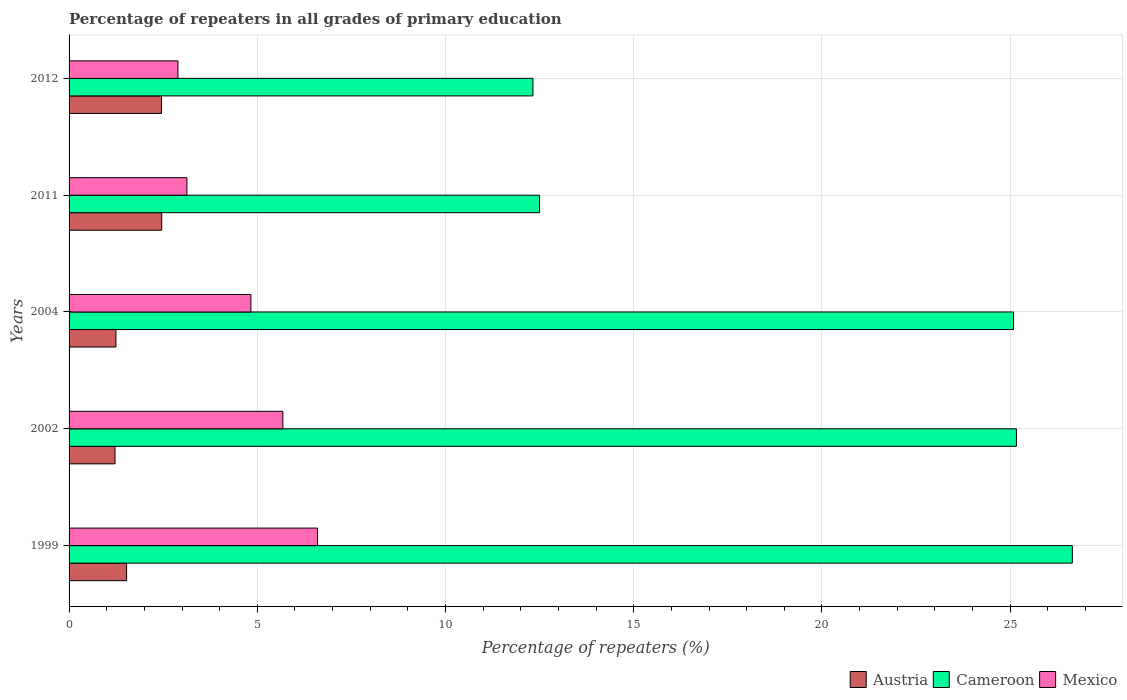How many different coloured bars are there?
Provide a short and direct response. 3. How many groups of bars are there?
Provide a succinct answer. 5. Are the number of bars per tick equal to the number of legend labels?
Your answer should be very brief. Yes. How many bars are there on the 2nd tick from the top?
Your answer should be very brief. 3. What is the label of the 2nd group of bars from the top?
Give a very brief answer. 2011. What is the percentage of repeaters in Cameroon in 2011?
Your response must be concise. 12.5. Across all years, what is the maximum percentage of repeaters in Austria?
Your answer should be compact. 2.46. Across all years, what is the minimum percentage of repeaters in Austria?
Give a very brief answer. 1.22. In which year was the percentage of repeaters in Cameroon minimum?
Provide a short and direct response. 2012. What is the total percentage of repeaters in Austria in the graph?
Offer a very short reply. 8.91. What is the difference between the percentage of repeaters in Cameroon in 1999 and that in 2004?
Keep it short and to the point. 1.56. What is the difference between the percentage of repeaters in Cameroon in 2012 and the percentage of repeaters in Mexico in 2002?
Keep it short and to the point. 6.64. What is the average percentage of repeaters in Austria per year?
Your response must be concise. 1.78. In the year 2002, what is the difference between the percentage of repeaters in Austria and percentage of repeaters in Mexico?
Your response must be concise. -4.46. In how many years, is the percentage of repeaters in Mexico greater than 16 %?
Offer a terse response. 0. What is the ratio of the percentage of repeaters in Mexico in 2004 to that in 2011?
Offer a very short reply. 1.54. Is the percentage of repeaters in Mexico in 1999 less than that in 2011?
Make the answer very short. No. Is the difference between the percentage of repeaters in Austria in 1999 and 2012 greater than the difference between the percentage of repeaters in Mexico in 1999 and 2012?
Ensure brevity in your answer.  No. What is the difference between the highest and the second highest percentage of repeaters in Cameroon?
Keep it short and to the point. 1.48. What is the difference between the highest and the lowest percentage of repeaters in Austria?
Provide a short and direct response. 1.24. In how many years, is the percentage of repeaters in Austria greater than the average percentage of repeaters in Austria taken over all years?
Offer a terse response. 2. What does the 2nd bar from the bottom in 2012 represents?
Your answer should be compact. Cameroon. Are the values on the major ticks of X-axis written in scientific E-notation?
Keep it short and to the point. No. Where does the legend appear in the graph?
Make the answer very short. Bottom right. How many legend labels are there?
Provide a short and direct response. 3. How are the legend labels stacked?
Give a very brief answer. Horizontal. What is the title of the graph?
Your answer should be compact. Percentage of repeaters in all grades of primary education. Does "Eritrea" appear as one of the legend labels in the graph?
Provide a succinct answer. No. What is the label or title of the X-axis?
Your response must be concise. Percentage of repeaters (%). What is the Percentage of repeaters (%) in Austria in 1999?
Offer a very short reply. 1.53. What is the Percentage of repeaters (%) in Cameroon in 1999?
Provide a short and direct response. 26.65. What is the Percentage of repeaters (%) of Mexico in 1999?
Your response must be concise. 6.6. What is the Percentage of repeaters (%) in Austria in 2002?
Ensure brevity in your answer.  1.22. What is the Percentage of repeaters (%) of Cameroon in 2002?
Give a very brief answer. 25.17. What is the Percentage of repeaters (%) in Mexico in 2002?
Provide a succinct answer. 5.68. What is the Percentage of repeaters (%) in Austria in 2004?
Your response must be concise. 1.24. What is the Percentage of repeaters (%) in Cameroon in 2004?
Provide a succinct answer. 25.09. What is the Percentage of repeaters (%) in Mexico in 2004?
Keep it short and to the point. 4.83. What is the Percentage of repeaters (%) in Austria in 2011?
Provide a short and direct response. 2.46. What is the Percentage of repeaters (%) of Cameroon in 2011?
Offer a terse response. 12.5. What is the Percentage of repeaters (%) of Mexico in 2011?
Provide a short and direct response. 3.13. What is the Percentage of repeaters (%) of Austria in 2012?
Provide a succinct answer. 2.46. What is the Percentage of repeaters (%) in Cameroon in 2012?
Give a very brief answer. 12.32. What is the Percentage of repeaters (%) of Mexico in 2012?
Give a very brief answer. 2.89. Across all years, what is the maximum Percentage of repeaters (%) of Austria?
Make the answer very short. 2.46. Across all years, what is the maximum Percentage of repeaters (%) of Cameroon?
Your answer should be compact. 26.65. Across all years, what is the maximum Percentage of repeaters (%) in Mexico?
Make the answer very short. 6.6. Across all years, what is the minimum Percentage of repeaters (%) of Austria?
Provide a succinct answer. 1.22. Across all years, what is the minimum Percentage of repeaters (%) of Cameroon?
Give a very brief answer. 12.32. Across all years, what is the minimum Percentage of repeaters (%) in Mexico?
Your response must be concise. 2.89. What is the total Percentage of repeaters (%) of Austria in the graph?
Keep it short and to the point. 8.91. What is the total Percentage of repeaters (%) of Cameroon in the graph?
Ensure brevity in your answer.  101.72. What is the total Percentage of repeaters (%) of Mexico in the graph?
Offer a very short reply. 23.13. What is the difference between the Percentage of repeaters (%) in Austria in 1999 and that in 2002?
Keep it short and to the point. 0.31. What is the difference between the Percentage of repeaters (%) in Cameroon in 1999 and that in 2002?
Make the answer very short. 1.48. What is the difference between the Percentage of repeaters (%) in Mexico in 1999 and that in 2002?
Ensure brevity in your answer.  0.92. What is the difference between the Percentage of repeaters (%) in Austria in 1999 and that in 2004?
Offer a terse response. 0.28. What is the difference between the Percentage of repeaters (%) of Cameroon in 1999 and that in 2004?
Offer a terse response. 1.56. What is the difference between the Percentage of repeaters (%) in Mexico in 1999 and that in 2004?
Offer a very short reply. 1.77. What is the difference between the Percentage of repeaters (%) of Austria in 1999 and that in 2011?
Your answer should be very brief. -0.93. What is the difference between the Percentage of repeaters (%) of Cameroon in 1999 and that in 2011?
Ensure brevity in your answer.  14.15. What is the difference between the Percentage of repeaters (%) of Mexico in 1999 and that in 2011?
Your answer should be compact. 3.47. What is the difference between the Percentage of repeaters (%) of Austria in 1999 and that in 2012?
Your answer should be very brief. -0.93. What is the difference between the Percentage of repeaters (%) in Cameroon in 1999 and that in 2012?
Make the answer very short. 14.33. What is the difference between the Percentage of repeaters (%) of Mexico in 1999 and that in 2012?
Keep it short and to the point. 3.71. What is the difference between the Percentage of repeaters (%) of Austria in 2002 and that in 2004?
Ensure brevity in your answer.  -0.02. What is the difference between the Percentage of repeaters (%) in Cameroon in 2002 and that in 2004?
Give a very brief answer. 0.08. What is the difference between the Percentage of repeaters (%) in Mexico in 2002 and that in 2004?
Give a very brief answer. 0.85. What is the difference between the Percentage of repeaters (%) in Austria in 2002 and that in 2011?
Your answer should be compact. -1.24. What is the difference between the Percentage of repeaters (%) of Cameroon in 2002 and that in 2011?
Keep it short and to the point. 12.67. What is the difference between the Percentage of repeaters (%) in Mexico in 2002 and that in 2011?
Provide a succinct answer. 2.55. What is the difference between the Percentage of repeaters (%) in Austria in 2002 and that in 2012?
Keep it short and to the point. -1.24. What is the difference between the Percentage of repeaters (%) in Cameroon in 2002 and that in 2012?
Keep it short and to the point. 12.84. What is the difference between the Percentage of repeaters (%) of Mexico in 2002 and that in 2012?
Make the answer very short. 2.79. What is the difference between the Percentage of repeaters (%) in Austria in 2004 and that in 2011?
Your answer should be compact. -1.22. What is the difference between the Percentage of repeaters (%) in Cameroon in 2004 and that in 2011?
Make the answer very short. 12.59. What is the difference between the Percentage of repeaters (%) of Mexico in 2004 and that in 2011?
Offer a very short reply. 1.7. What is the difference between the Percentage of repeaters (%) of Austria in 2004 and that in 2012?
Provide a succinct answer. -1.21. What is the difference between the Percentage of repeaters (%) in Cameroon in 2004 and that in 2012?
Provide a short and direct response. 12.77. What is the difference between the Percentage of repeaters (%) of Mexico in 2004 and that in 2012?
Ensure brevity in your answer.  1.94. What is the difference between the Percentage of repeaters (%) in Austria in 2011 and that in 2012?
Your answer should be compact. 0. What is the difference between the Percentage of repeaters (%) of Cameroon in 2011 and that in 2012?
Offer a very short reply. 0.17. What is the difference between the Percentage of repeaters (%) of Mexico in 2011 and that in 2012?
Offer a terse response. 0.24. What is the difference between the Percentage of repeaters (%) in Austria in 1999 and the Percentage of repeaters (%) in Cameroon in 2002?
Keep it short and to the point. -23.64. What is the difference between the Percentage of repeaters (%) of Austria in 1999 and the Percentage of repeaters (%) of Mexico in 2002?
Offer a very short reply. -4.15. What is the difference between the Percentage of repeaters (%) in Cameroon in 1999 and the Percentage of repeaters (%) in Mexico in 2002?
Your answer should be compact. 20.97. What is the difference between the Percentage of repeaters (%) of Austria in 1999 and the Percentage of repeaters (%) of Cameroon in 2004?
Ensure brevity in your answer.  -23.56. What is the difference between the Percentage of repeaters (%) in Austria in 1999 and the Percentage of repeaters (%) in Mexico in 2004?
Your answer should be compact. -3.3. What is the difference between the Percentage of repeaters (%) of Cameroon in 1999 and the Percentage of repeaters (%) of Mexico in 2004?
Offer a terse response. 21.82. What is the difference between the Percentage of repeaters (%) of Austria in 1999 and the Percentage of repeaters (%) of Cameroon in 2011?
Your response must be concise. -10.97. What is the difference between the Percentage of repeaters (%) in Austria in 1999 and the Percentage of repeaters (%) in Mexico in 2011?
Make the answer very short. -1.6. What is the difference between the Percentage of repeaters (%) in Cameroon in 1999 and the Percentage of repeaters (%) in Mexico in 2011?
Offer a very short reply. 23.52. What is the difference between the Percentage of repeaters (%) of Austria in 1999 and the Percentage of repeaters (%) of Cameroon in 2012?
Your answer should be very brief. -10.79. What is the difference between the Percentage of repeaters (%) of Austria in 1999 and the Percentage of repeaters (%) of Mexico in 2012?
Make the answer very short. -1.36. What is the difference between the Percentage of repeaters (%) of Cameroon in 1999 and the Percentage of repeaters (%) of Mexico in 2012?
Provide a succinct answer. 23.76. What is the difference between the Percentage of repeaters (%) in Austria in 2002 and the Percentage of repeaters (%) in Cameroon in 2004?
Your answer should be very brief. -23.87. What is the difference between the Percentage of repeaters (%) in Austria in 2002 and the Percentage of repeaters (%) in Mexico in 2004?
Give a very brief answer. -3.61. What is the difference between the Percentage of repeaters (%) of Cameroon in 2002 and the Percentage of repeaters (%) of Mexico in 2004?
Give a very brief answer. 20.34. What is the difference between the Percentage of repeaters (%) in Austria in 2002 and the Percentage of repeaters (%) in Cameroon in 2011?
Give a very brief answer. -11.28. What is the difference between the Percentage of repeaters (%) of Austria in 2002 and the Percentage of repeaters (%) of Mexico in 2011?
Provide a short and direct response. -1.91. What is the difference between the Percentage of repeaters (%) in Cameroon in 2002 and the Percentage of repeaters (%) in Mexico in 2011?
Your answer should be compact. 22.04. What is the difference between the Percentage of repeaters (%) in Austria in 2002 and the Percentage of repeaters (%) in Cameroon in 2012?
Your answer should be very brief. -11.1. What is the difference between the Percentage of repeaters (%) of Austria in 2002 and the Percentage of repeaters (%) of Mexico in 2012?
Provide a short and direct response. -1.67. What is the difference between the Percentage of repeaters (%) in Cameroon in 2002 and the Percentage of repeaters (%) in Mexico in 2012?
Make the answer very short. 22.27. What is the difference between the Percentage of repeaters (%) in Austria in 2004 and the Percentage of repeaters (%) in Cameroon in 2011?
Make the answer very short. -11.25. What is the difference between the Percentage of repeaters (%) of Austria in 2004 and the Percentage of repeaters (%) of Mexico in 2011?
Your answer should be compact. -1.88. What is the difference between the Percentage of repeaters (%) in Cameroon in 2004 and the Percentage of repeaters (%) in Mexico in 2011?
Your response must be concise. 21.96. What is the difference between the Percentage of repeaters (%) of Austria in 2004 and the Percentage of repeaters (%) of Cameroon in 2012?
Ensure brevity in your answer.  -11.08. What is the difference between the Percentage of repeaters (%) in Austria in 2004 and the Percentage of repeaters (%) in Mexico in 2012?
Your response must be concise. -1.65. What is the difference between the Percentage of repeaters (%) in Cameroon in 2004 and the Percentage of repeaters (%) in Mexico in 2012?
Provide a short and direct response. 22.2. What is the difference between the Percentage of repeaters (%) of Austria in 2011 and the Percentage of repeaters (%) of Cameroon in 2012?
Offer a terse response. -9.86. What is the difference between the Percentage of repeaters (%) of Austria in 2011 and the Percentage of repeaters (%) of Mexico in 2012?
Offer a very short reply. -0.43. What is the difference between the Percentage of repeaters (%) of Cameroon in 2011 and the Percentage of repeaters (%) of Mexico in 2012?
Make the answer very short. 9.6. What is the average Percentage of repeaters (%) of Austria per year?
Keep it short and to the point. 1.78. What is the average Percentage of repeaters (%) in Cameroon per year?
Offer a terse response. 20.34. What is the average Percentage of repeaters (%) in Mexico per year?
Your answer should be very brief. 4.63. In the year 1999, what is the difference between the Percentage of repeaters (%) in Austria and Percentage of repeaters (%) in Cameroon?
Your answer should be compact. -25.12. In the year 1999, what is the difference between the Percentage of repeaters (%) in Austria and Percentage of repeaters (%) in Mexico?
Offer a very short reply. -5.07. In the year 1999, what is the difference between the Percentage of repeaters (%) of Cameroon and Percentage of repeaters (%) of Mexico?
Your response must be concise. 20.05. In the year 2002, what is the difference between the Percentage of repeaters (%) of Austria and Percentage of repeaters (%) of Cameroon?
Your answer should be compact. -23.94. In the year 2002, what is the difference between the Percentage of repeaters (%) of Austria and Percentage of repeaters (%) of Mexico?
Keep it short and to the point. -4.46. In the year 2002, what is the difference between the Percentage of repeaters (%) of Cameroon and Percentage of repeaters (%) of Mexico?
Provide a succinct answer. 19.49. In the year 2004, what is the difference between the Percentage of repeaters (%) in Austria and Percentage of repeaters (%) in Cameroon?
Provide a short and direct response. -23.84. In the year 2004, what is the difference between the Percentage of repeaters (%) in Austria and Percentage of repeaters (%) in Mexico?
Ensure brevity in your answer.  -3.58. In the year 2004, what is the difference between the Percentage of repeaters (%) in Cameroon and Percentage of repeaters (%) in Mexico?
Keep it short and to the point. 20.26. In the year 2011, what is the difference between the Percentage of repeaters (%) in Austria and Percentage of repeaters (%) in Cameroon?
Provide a short and direct response. -10.03. In the year 2011, what is the difference between the Percentage of repeaters (%) in Austria and Percentage of repeaters (%) in Mexico?
Offer a terse response. -0.67. In the year 2011, what is the difference between the Percentage of repeaters (%) of Cameroon and Percentage of repeaters (%) of Mexico?
Keep it short and to the point. 9.37. In the year 2012, what is the difference between the Percentage of repeaters (%) in Austria and Percentage of repeaters (%) in Cameroon?
Provide a short and direct response. -9.87. In the year 2012, what is the difference between the Percentage of repeaters (%) in Austria and Percentage of repeaters (%) in Mexico?
Your answer should be very brief. -0.44. In the year 2012, what is the difference between the Percentage of repeaters (%) of Cameroon and Percentage of repeaters (%) of Mexico?
Your answer should be very brief. 9.43. What is the ratio of the Percentage of repeaters (%) of Austria in 1999 to that in 2002?
Give a very brief answer. 1.25. What is the ratio of the Percentage of repeaters (%) in Cameroon in 1999 to that in 2002?
Keep it short and to the point. 1.06. What is the ratio of the Percentage of repeaters (%) of Mexico in 1999 to that in 2002?
Keep it short and to the point. 1.16. What is the ratio of the Percentage of repeaters (%) in Austria in 1999 to that in 2004?
Offer a very short reply. 1.23. What is the ratio of the Percentage of repeaters (%) in Cameroon in 1999 to that in 2004?
Your answer should be compact. 1.06. What is the ratio of the Percentage of repeaters (%) of Mexico in 1999 to that in 2004?
Offer a very short reply. 1.37. What is the ratio of the Percentage of repeaters (%) in Austria in 1999 to that in 2011?
Ensure brevity in your answer.  0.62. What is the ratio of the Percentage of repeaters (%) in Cameroon in 1999 to that in 2011?
Your response must be concise. 2.13. What is the ratio of the Percentage of repeaters (%) of Mexico in 1999 to that in 2011?
Your answer should be compact. 2.11. What is the ratio of the Percentage of repeaters (%) of Austria in 1999 to that in 2012?
Offer a terse response. 0.62. What is the ratio of the Percentage of repeaters (%) in Cameroon in 1999 to that in 2012?
Offer a terse response. 2.16. What is the ratio of the Percentage of repeaters (%) of Mexico in 1999 to that in 2012?
Your response must be concise. 2.28. What is the ratio of the Percentage of repeaters (%) of Austria in 2002 to that in 2004?
Ensure brevity in your answer.  0.98. What is the ratio of the Percentage of repeaters (%) of Mexico in 2002 to that in 2004?
Ensure brevity in your answer.  1.18. What is the ratio of the Percentage of repeaters (%) in Austria in 2002 to that in 2011?
Provide a short and direct response. 0.5. What is the ratio of the Percentage of repeaters (%) of Cameroon in 2002 to that in 2011?
Offer a very short reply. 2.01. What is the ratio of the Percentage of repeaters (%) of Mexico in 2002 to that in 2011?
Your answer should be compact. 1.81. What is the ratio of the Percentage of repeaters (%) in Austria in 2002 to that in 2012?
Your answer should be very brief. 0.5. What is the ratio of the Percentage of repeaters (%) in Cameroon in 2002 to that in 2012?
Keep it short and to the point. 2.04. What is the ratio of the Percentage of repeaters (%) in Mexico in 2002 to that in 2012?
Provide a succinct answer. 1.96. What is the ratio of the Percentage of repeaters (%) of Austria in 2004 to that in 2011?
Your answer should be compact. 0.51. What is the ratio of the Percentage of repeaters (%) of Cameroon in 2004 to that in 2011?
Make the answer very short. 2.01. What is the ratio of the Percentage of repeaters (%) in Mexico in 2004 to that in 2011?
Your response must be concise. 1.54. What is the ratio of the Percentage of repeaters (%) of Austria in 2004 to that in 2012?
Your answer should be compact. 0.51. What is the ratio of the Percentage of repeaters (%) of Cameroon in 2004 to that in 2012?
Offer a very short reply. 2.04. What is the ratio of the Percentage of repeaters (%) of Mexico in 2004 to that in 2012?
Your answer should be very brief. 1.67. What is the ratio of the Percentage of repeaters (%) of Cameroon in 2011 to that in 2012?
Offer a very short reply. 1.01. What is the ratio of the Percentage of repeaters (%) of Mexico in 2011 to that in 2012?
Keep it short and to the point. 1.08. What is the difference between the highest and the second highest Percentage of repeaters (%) in Austria?
Make the answer very short. 0. What is the difference between the highest and the second highest Percentage of repeaters (%) of Cameroon?
Your answer should be compact. 1.48. What is the difference between the highest and the second highest Percentage of repeaters (%) in Mexico?
Offer a terse response. 0.92. What is the difference between the highest and the lowest Percentage of repeaters (%) in Austria?
Keep it short and to the point. 1.24. What is the difference between the highest and the lowest Percentage of repeaters (%) of Cameroon?
Provide a short and direct response. 14.33. What is the difference between the highest and the lowest Percentage of repeaters (%) of Mexico?
Provide a succinct answer. 3.71. 